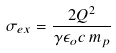Convert formula to latex. <formula><loc_0><loc_0><loc_500><loc_500>\sigma _ { e x } = \frac { 2 Q ^ { 2 } } { \gamma \epsilon _ { o } c \, m _ { p } }</formula> 